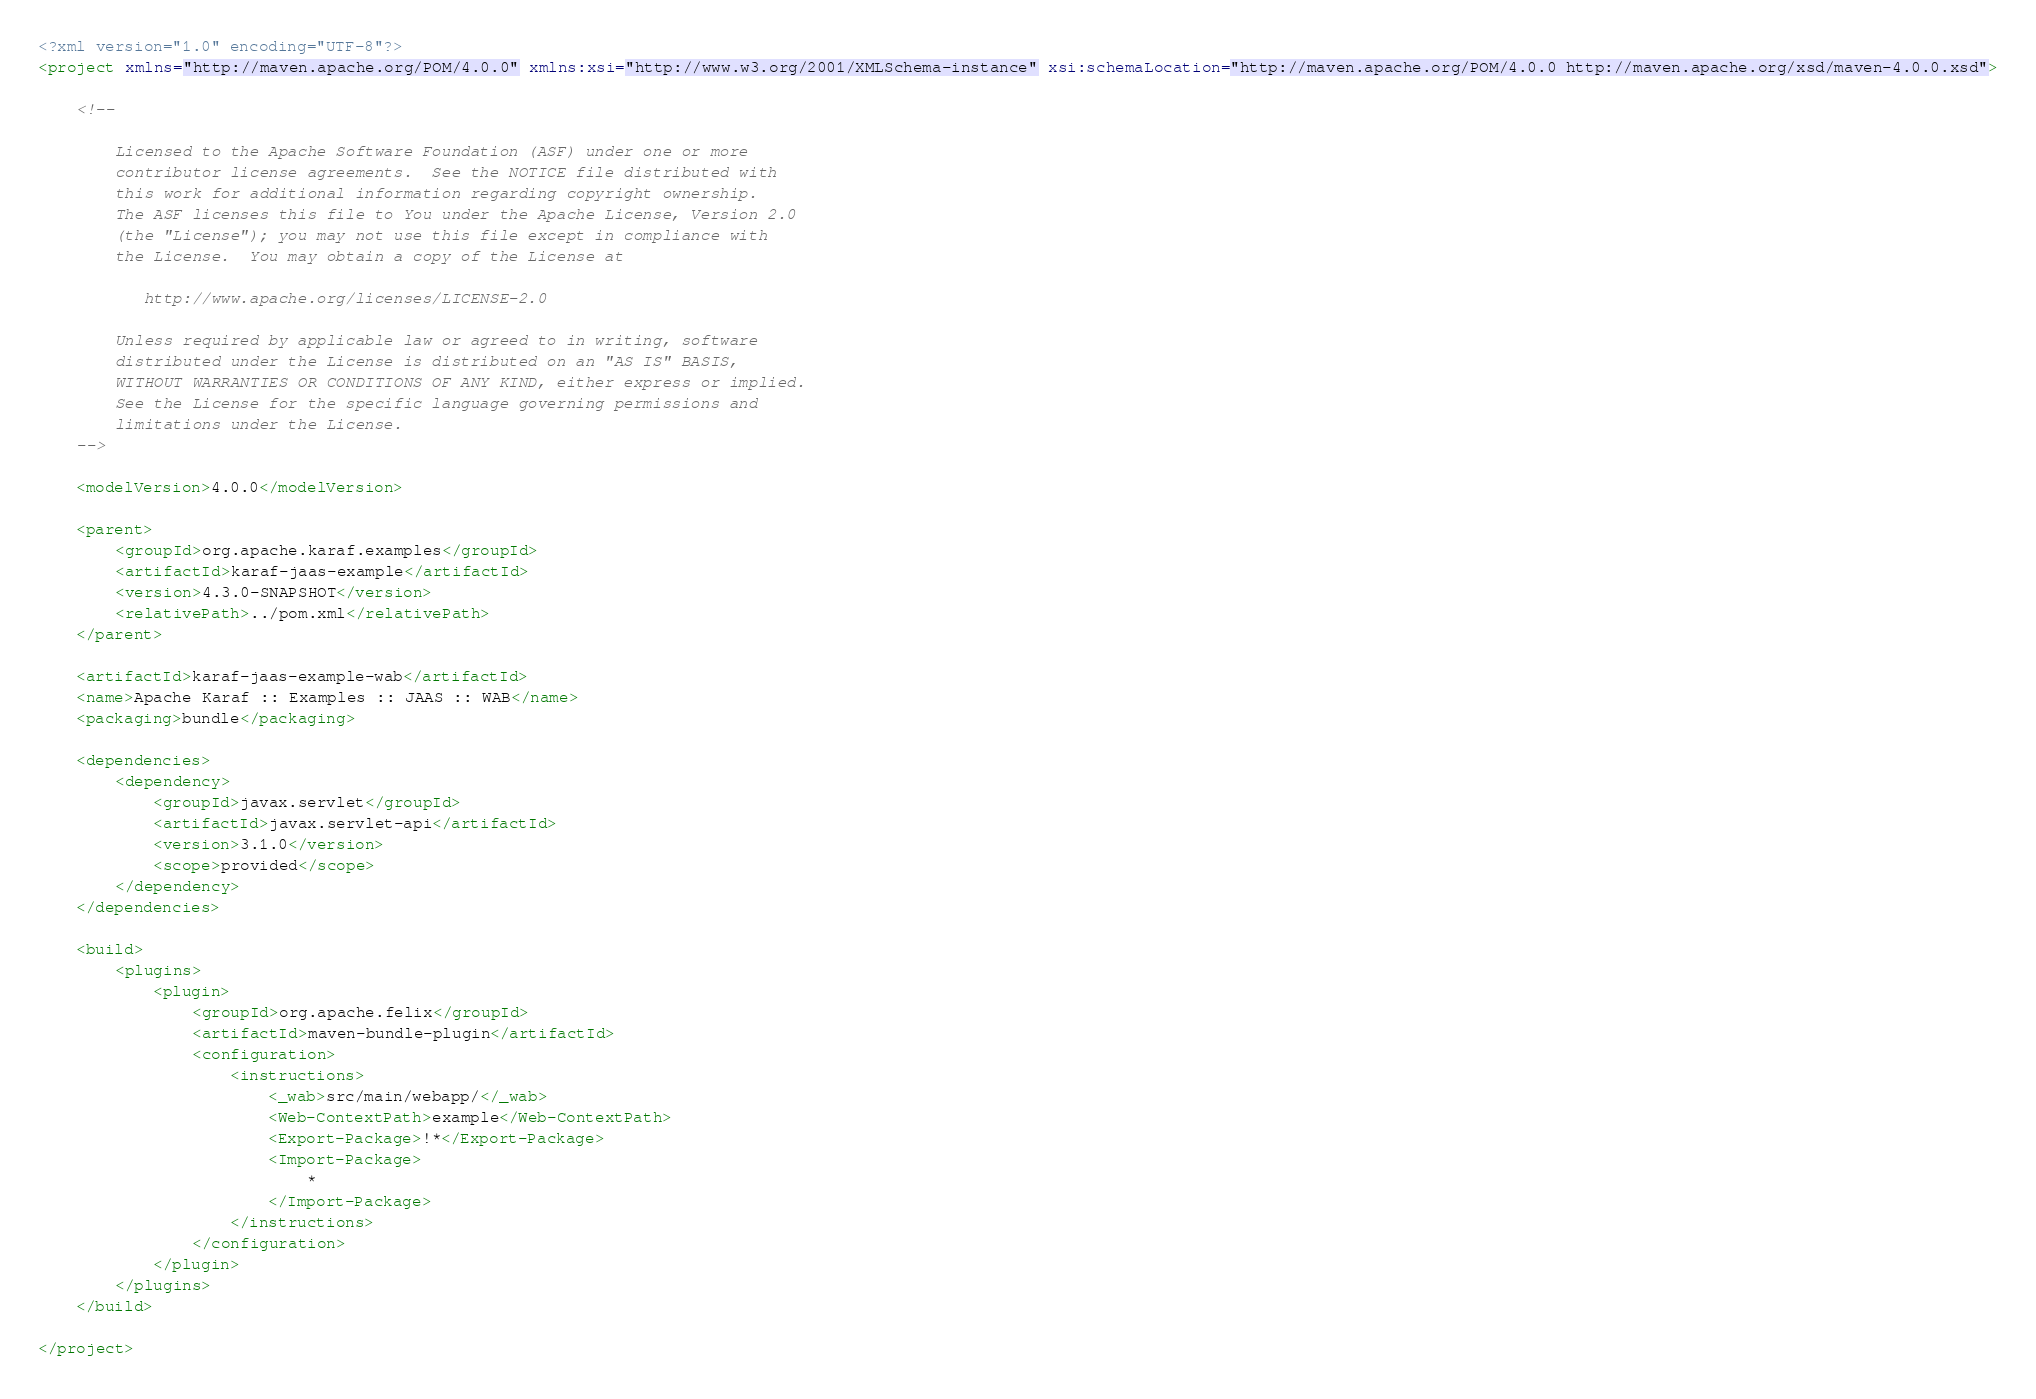Convert code to text. <code><loc_0><loc_0><loc_500><loc_500><_XML_><?xml version="1.0" encoding="UTF-8"?>
<project xmlns="http://maven.apache.org/POM/4.0.0" xmlns:xsi="http://www.w3.org/2001/XMLSchema-instance" xsi:schemaLocation="http://maven.apache.org/POM/4.0.0 http://maven.apache.org/xsd/maven-4.0.0.xsd">

    <!--

        Licensed to the Apache Software Foundation (ASF) under one or more
        contributor license agreements.  See the NOTICE file distributed with
        this work for additional information regarding copyright ownership.
        The ASF licenses this file to You under the Apache License, Version 2.0
        (the "License"); you may not use this file except in compliance with
        the License.  You may obtain a copy of the License at

           http://www.apache.org/licenses/LICENSE-2.0

        Unless required by applicable law or agreed to in writing, software
        distributed under the License is distributed on an "AS IS" BASIS,
        WITHOUT WARRANTIES OR CONDITIONS OF ANY KIND, either express or implied.
        See the License for the specific language governing permissions and
        limitations under the License.
    -->

    <modelVersion>4.0.0</modelVersion>

    <parent>
        <groupId>org.apache.karaf.examples</groupId>
        <artifactId>karaf-jaas-example</artifactId>
        <version>4.3.0-SNAPSHOT</version>
        <relativePath>../pom.xml</relativePath>
    </parent>

    <artifactId>karaf-jaas-example-wab</artifactId>
    <name>Apache Karaf :: Examples :: JAAS :: WAB</name>
    <packaging>bundle</packaging>

    <dependencies>
        <dependency>
            <groupId>javax.servlet</groupId>
            <artifactId>javax.servlet-api</artifactId>
            <version>3.1.0</version>
            <scope>provided</scope>
        </dependency>
    </dependencies>

    <build>
        <plugins>
            <plugin>
                <groupId>org.apache.felix</groupId>
                <artifactId>maven-bundle-plugin</artifactId>
                <configuration>
                    <instructions>
                        <_wab>src/main/webapp/</_wab>
                        <Web-ContextPath>example</Web-ContextPath>
                        <Export-Package>!*</Export-Package>
                        <Import-Package>
                            *
                        </Import-Package>
                    </instructions>
                </configuration>
            </plugin>
        </plugins>
    </build>

</project></code> 